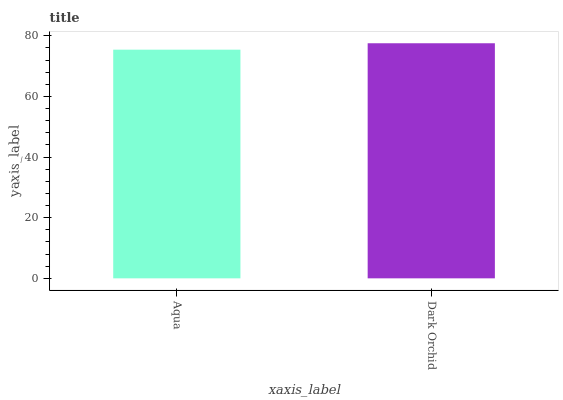Is Aqua the minimum?
Answer yes or no. Yes. Is Dark Orchid the maximum?
Answer yes or no. Yes. Is Dark Orchid the minimum?
Answer yes or no. No. Is Dark Orchid greater than Aqua?
Answer yes or no. Yes. Is Aqua less than Dark Orchid?
Answer yes or no. Yes. Is Aqua greater than Dark Orchid?
Answer yes or no. No. Is Dark Orchid less than Aqua?
Answer yes or no. No. Is Dark Orchid the high median?
Answer yes or no. Yes. Is Aqua the low median?
Answer yes or no. Yes. Is Aqua the high median?
Answer yes or no. No. Is Dark Orchid the low median?
Answer yes or no. No. 